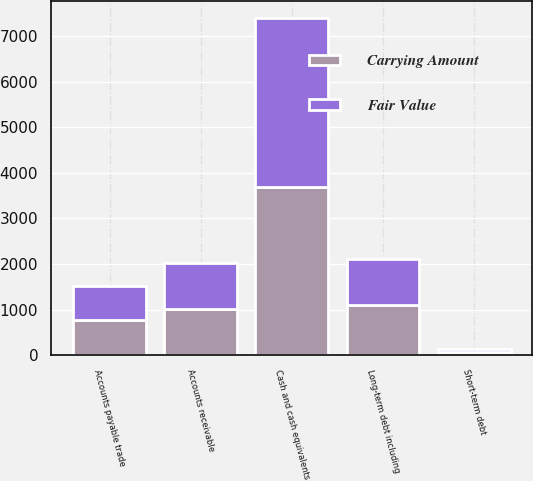<chart> <loc_0><loc_0><loc_500><loc_500><stacked_bar_chart><ecel><fcel>Cash and cash equivalents<fcel>Accounts receivable<fcel>Accounts payable trade<fcel>Short-term debt<fcel>Long-term debt including<nl><fcel>Fair Value<fcel>3697.1<fcel>1015.7<fcel>763.1<fcel>68.7<fcel>1010.5<nl><fcel>Carrying Amount<fcel>3697.1<fcel>1015.7<fcel>763.1<fcel>68.7<fcel>1093.3<nl></chart> 